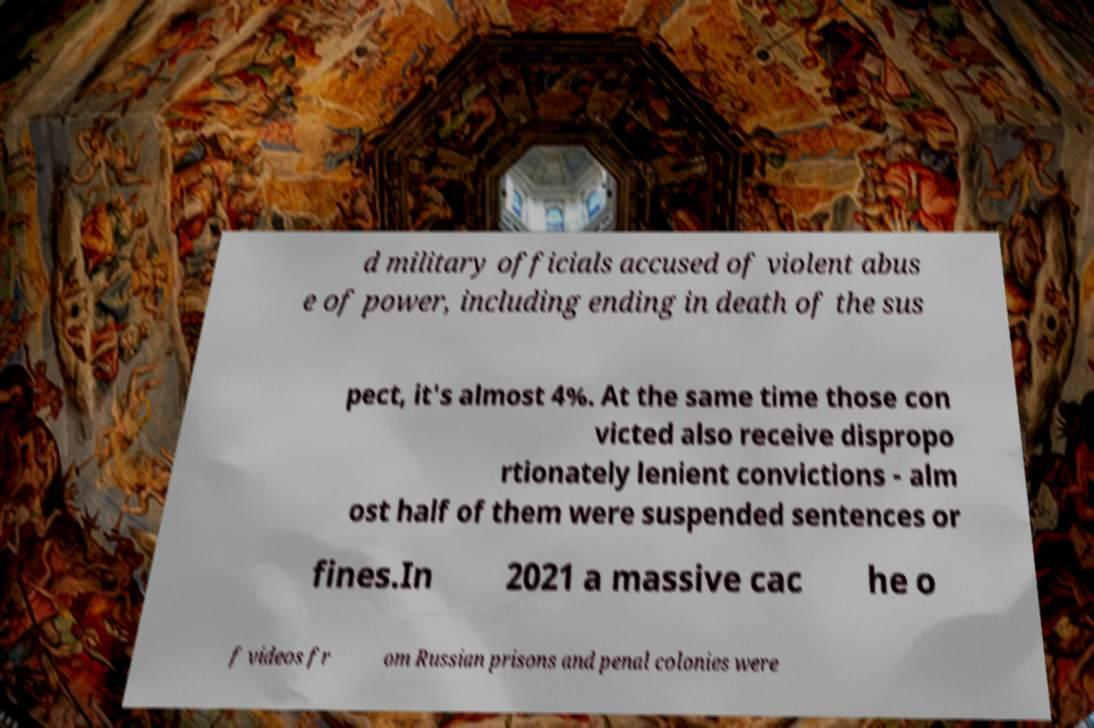There's text embedded in this image that I need extracted. Can you transcribe it verbatim? d military officials accused of violent abus e of power, including ending in death of the sus pect, it's almost 4%. At the same time those con victed also receive dispropo rtionately lenient convictions - alm ost half of them were suspended sentences or fines.In 2021 a massive cac he o f videos fr om Russian prisons and penal colonies were 